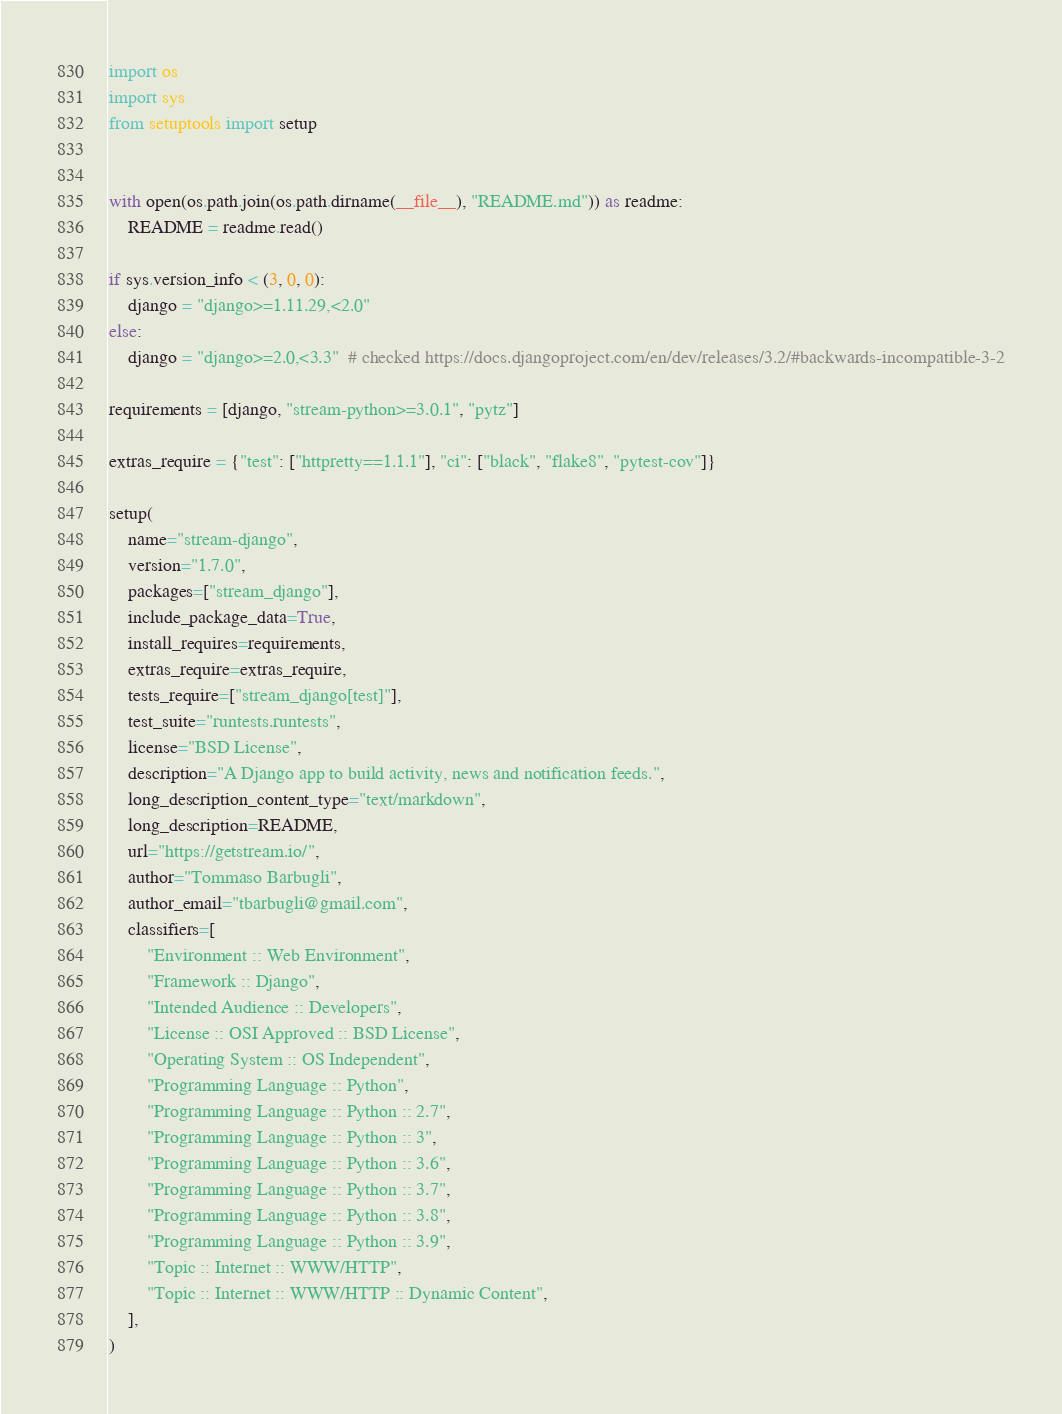Convert code to text. <code><loc_0><loc_0><loc_500><loc_500><_Python_>import os
import sys
from setuptools import setup


with open(os.path.join(os.path.dirname(__file__), "README.md")) as readme:
    README = readme.read()

if sys.version_info < (3, 0, 0):
    django = "django>=1.11.29,<2.0"
else:
    django = "django>=2.0,<3.3"  # checked https://docs.djangoproject.com/en/dev/releases/3.2/#backwards-incompatible-3-2

requirements = [django, "stream-python>=3.0.1", "pytz"]

extras_require = {"test": ["httpretty==1.1.1"], "ci": ["black", "flake8", "pytest-cov"]}

setup(
    name="stream-django",
    version="1.7.0",
    packages=["stream_django"],
    include_package_data=True,
    install_requires=requirements,
    extras_require=extras_require,
    tests_require=["stream_django[test]"],
    test_suite="runtests.runtests",
    license="BSD License",
    description="A Django app to build activity, news and notification feeds.",
    long_description_content_type="text/markdown",
    long_description=README,
    url="https://getstream.io/",
    author="Tommaso Barbugli",
    author_email="tbarbugli@gmail.com",
    classifiers=[
        "Environment :: Web Environment",
        "Framework :: Django",
        "Intended Audience :: Developers",
        "License :: OSI Approved :: BSD License",
        "Operating System :: OS Independent",
        "Programming Language :: Python",
        "Programming Language :: Python :: 2.7",
        "Programming Language :: Python :: 3",
        "Programming Language :: Python :: 3.6",
        "Programming Language :: Python :: 3.7",
        "Programming Language :: Python :: 3.8",
        "Programming Language :: Python :: 3.9",
        "Topic :: Internet :: WWW/HTTP",
        "Topic :: Internet :: WWW/HTTP :: Dynamic Content",
    ],
)
</code> 